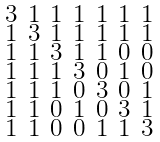Convert formula to latex. <formula><loc_0><loc_0><loc_500><loc_500>\begin{smallmatrix} 3 & 1 & 1 & 1 & 1 & 1 & 1 \\ 1 & 3 & 1 & 1 & 1 & 1 & 1 \\ 1 & 1 & 3 & 1 & 1 & 0 & 0 \\ 1 & 1 & 1 & 3 & 0 & 1 & 0 \\ 1 & 1 & 1 & 0 & 3 & 0 & 1 \\ 1 & 1 & 0 & 1 & 0 & 3 & 1 \\ 1 & 1 & 0 & 0 & 1 & 1 & 3 \end{smallmatrix}</formula> 